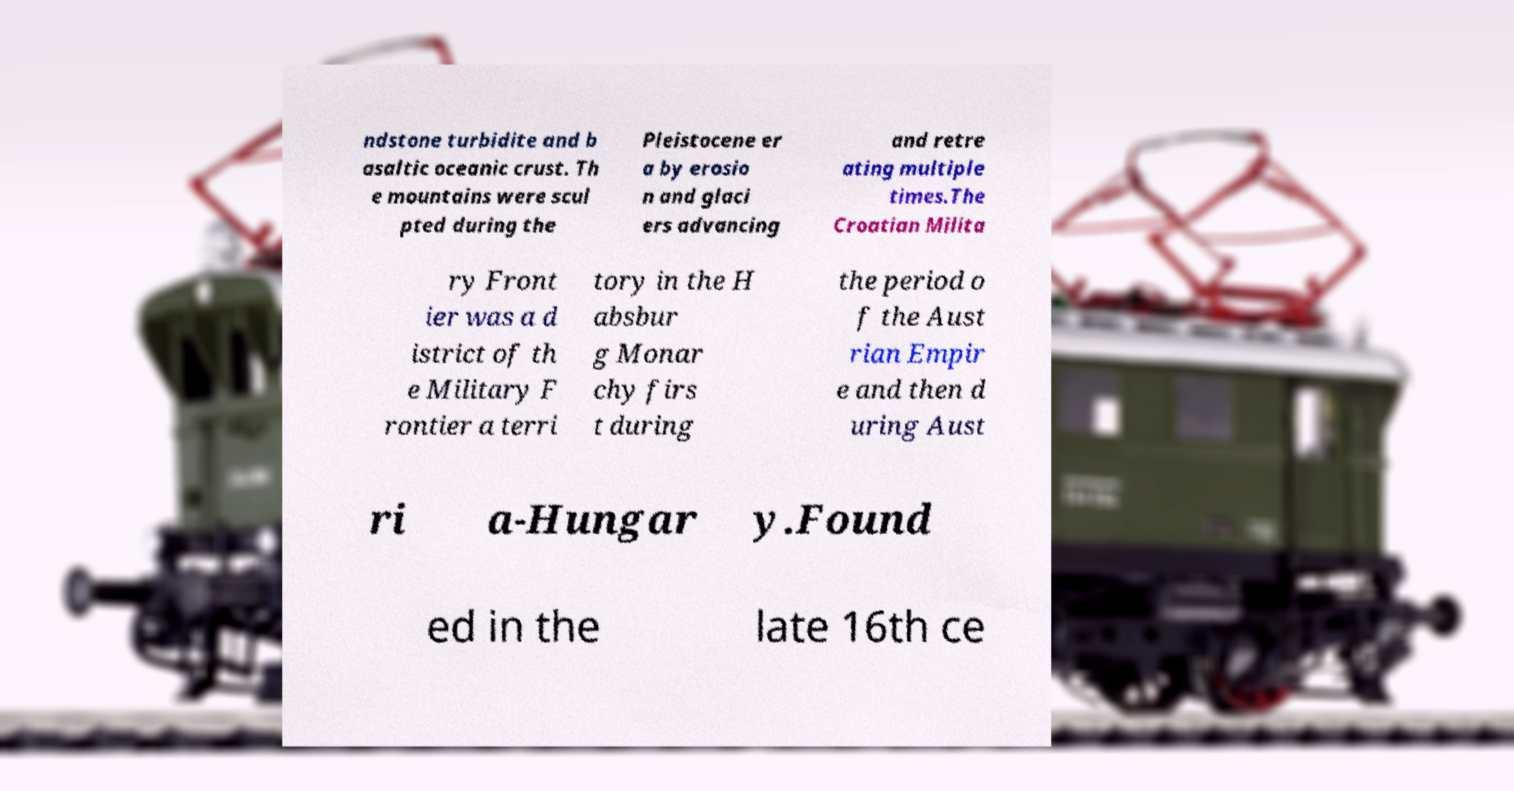Please identify and transcribe the text found in this image. ndstone turbidite and b asaltic oceanic crust. Th e mountains were scul pted during the Pleistocene er a by erosio n and glaci ers advancing and retre ating multiple times.The Croatian Milita ry Front ier was a d istrict of th e Military F rontier a terri tory in the H absbur g Monar chy firs t during the period o f the Aust rian Empir e and then d uring Aust ri a-Hungar y.Found ed in the late 16th ce 